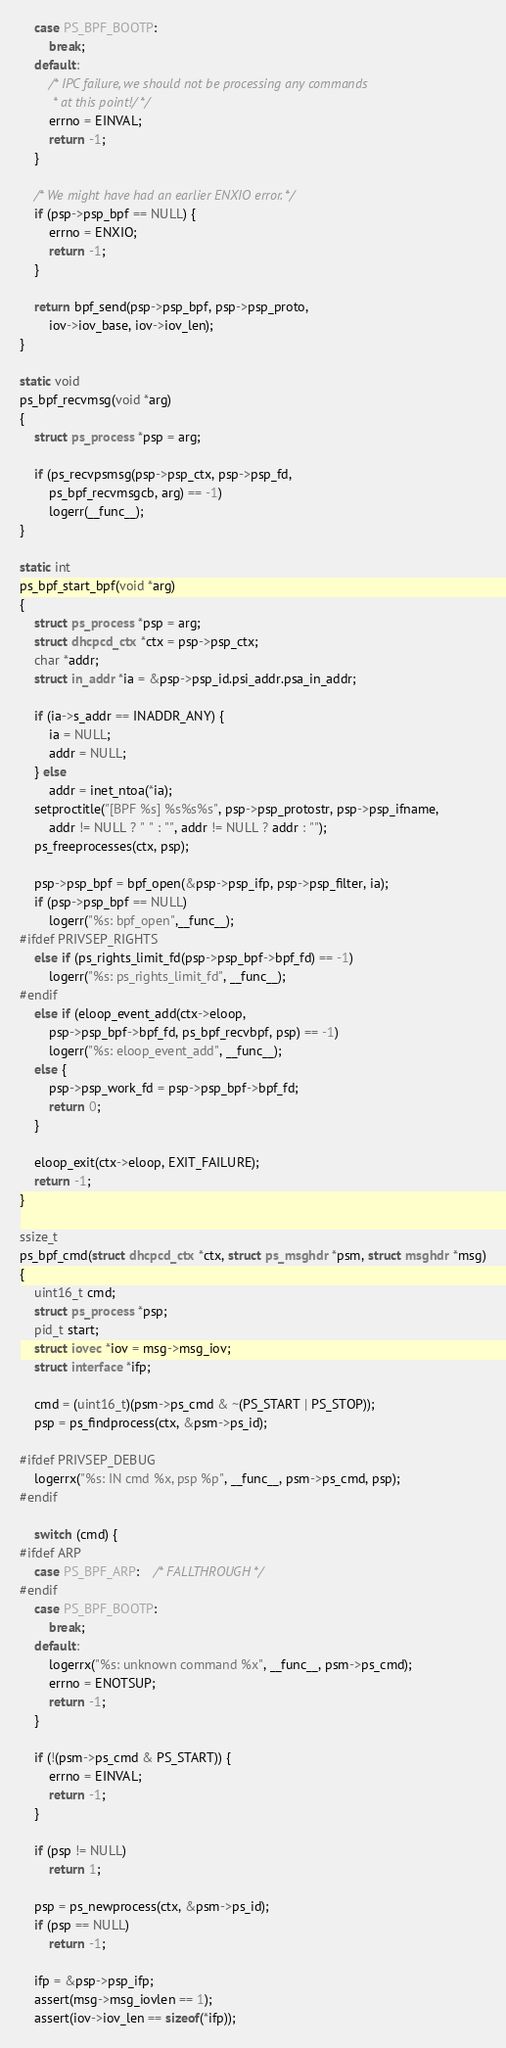<code> <loc_0><loc_0><loc_500><loc_500><_C_>	case PS_BPF_BOOTP:
		break;
	default:
		/* IPC failure, we should not be processing any commands
		 * at this point!/ */
		errno = EINVAL;
		return -1;
	}

	/* We might have had an earlier ENXIO error. */
	if (psp->psp_bpf == NULL) {
		errno = ENXIO;
		return -1;
	}

	return bpf_send(psp->psp_bpf, psp->psp_proto,
	    iov->iov_base, iov->iov_len);
}

static void
ps_bpf_recvmsg(void *arg)
{
	struct ps_process *psp = arg;

	if (ps_recvpsmsg(psp->psp_ctx, psp->psp_fd,
	    ps_bpf_recvmsgcb, arg) == -1)
		logerr(__func__);
}

static int
ps_bpf_start_bpf(void *arg)
{
	struct ps_process *psp = arg;
	struct dhcpcd_ctx *ctx = psp->psp_ctx;
	char *addr;
	struct in_addr *ia = &psp->psp_id.psi_addr.psa_in_addr;

	if (ia->s_addr == INADDR_ANY) {
		ia = NULL;
		addr = NULL;
	} else
		addr = inet_ntoa(*ia);
	setproctitle("[BPF %s] %s%s%s", psp->psp_protostr, psp->psp_ifname,
	    addr != NULL ? " " : "", addr != NULL ? addr : "");
	ps_freeprocesses(ctx, psp);

	psp->psp_bpf = bpf_open(&psp->psp_ifp, psp->psp_filter, ia);
	if (psp->psp_bpf == NULL)
		logerr("%s: bpf_open",__func__);
#ifdef PRIVSEP_RIGHTS
	else if (ps_rights_limit_fd(psp->psp_bpf->bpf_fd) == -1)
		logerr("%s: ps_rights_limit_fd", __func__);
#endif
	else if (eloop_event_add(ctx->eloop,
	    psp->psp_bpf->bpf_fd, ps_bpf_recvbpf, psp) == -1)
		logerr("%s: eloop_event_add", __func__);
	else {
		psp->psp_work_fd = psp->psp_bpf->bpf_fd;
		return 0;
	}

	eloop_exit(ctx->eloop, EXIT_FAILURE);
	return -1;
}

ssize_t
ps_bpf_cmd(struct dhcpcd_ctx *ctx, struct ps_msghdr *psm, struct msghdr *msg)
{
	uint16_t cmd;
	struct ps_process *psp;
	pid_t start;
	struct iovec *iov = msg->msg_iov;
	struct interface *ifp;

	cmd = (uint16_t)(psm->ps_cmd & ~(PS_START | PS_STOP));
	psp = ps_findprocess(ctx, &psm->ps_id);

#ifdef PRIVSEP_DEBUG
	logerrx("%s: IN cmd %x, psp %p", __func__, psm->ps_cmd, psp);
#endif

	switch (cmd) {
#ifdef ARP
	case PS_BPF_ARP:	/* FALLTHROUGH */
#endif
	case PS_BPF_BOOTP:
		break;
	default:
		logerrx("%s: unknown command %x", __func__, psm->ps_cmd);
		errno = ENOTSUP;
		return -1;
	}

	if (!(psm->ps_cmd & PS_START)) {
		errno = EINVAL;
		return -1;
	}

	if (psp != NULL)
		return 1;

	psp = ps_newprocess(ctx, &psm->ps_id);
	if (psp == NULL)
		return -1;

	ifp = &psp->psp_ifp;
	assert(msg->msg_iovlen == 1);
	assert(iov->iov_len == sizeof(*ifp));</code> 